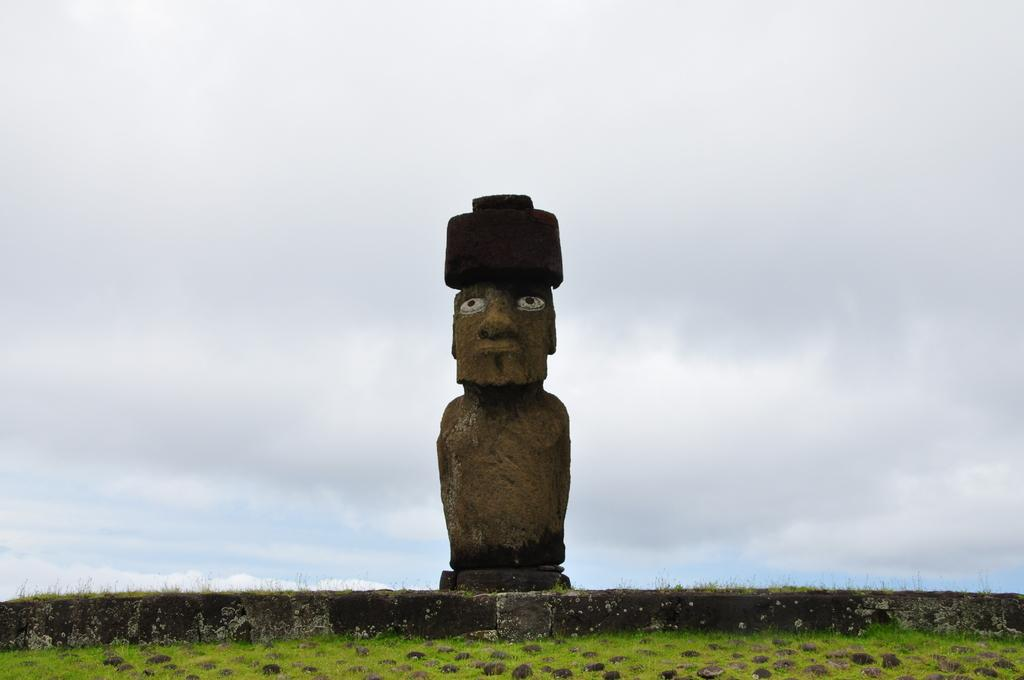What can be seen in the sky in the image? The sky is visible in the image. What type of artwork is present in the image? There is a sculpture of a person in the image. What type of vegetation is present in the image? There are plants and grass in the image. How is the grass depicted in the image? The grass appears to be truncated towards the bottom of the image. What type of loaf is being baked in the oven in the image? There is no oven or loaf present in the image. Is there a house visible in the image? No, there is no house visible in the image. 